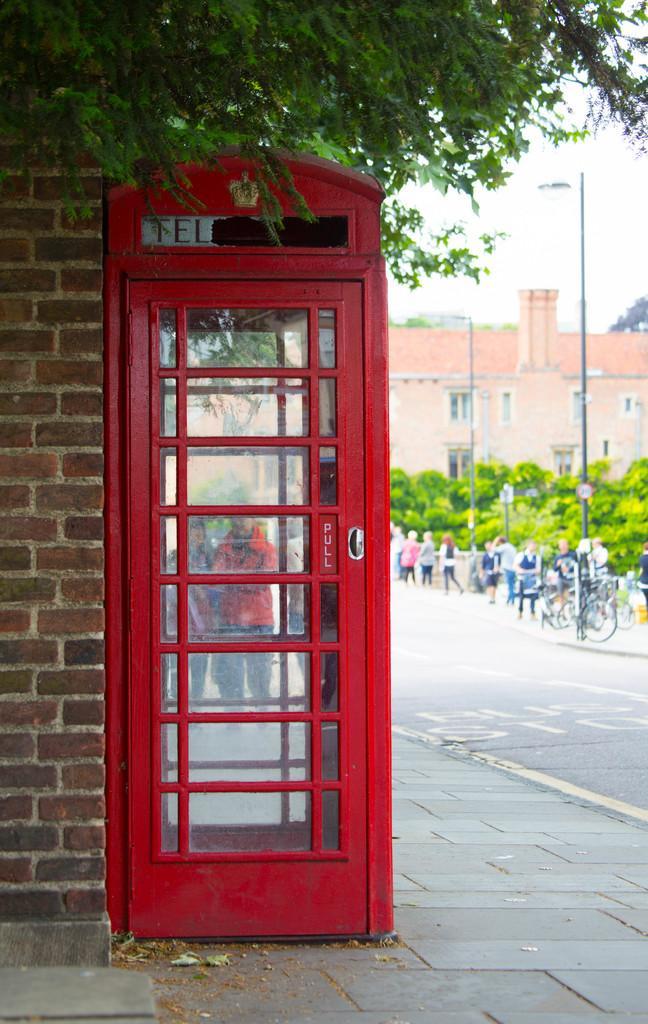How would you summarize this image in a sentence or two? In the middle of the image there is a telephone booth. Behind the telephone booth few people are standing and walking and there are some bicycles and trees and poles and sign boards. At the top of the image there is a tree. Behind the tree there is sky. 